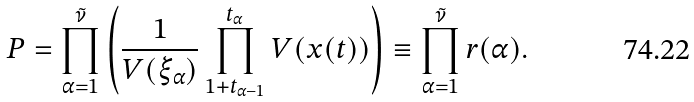Convert formula to latex. <formula><loc_0><loc_0><loc_500><loc_500>P = \prod _ { \alpha = 1 } ^ { \tilde { \nu } } \left ( \frac { 1 } { V ( \xi _ { \alpha } ) } \prod _ { 1 + t _ { \alpha - 1 } } ^ { t _ { \alpha } } V ( x ( t ) ) \right ) \equiv \prod _ { \alpha = 1 } ^ { \tilde { \nu } } r ( \alpha ) .</formula> 